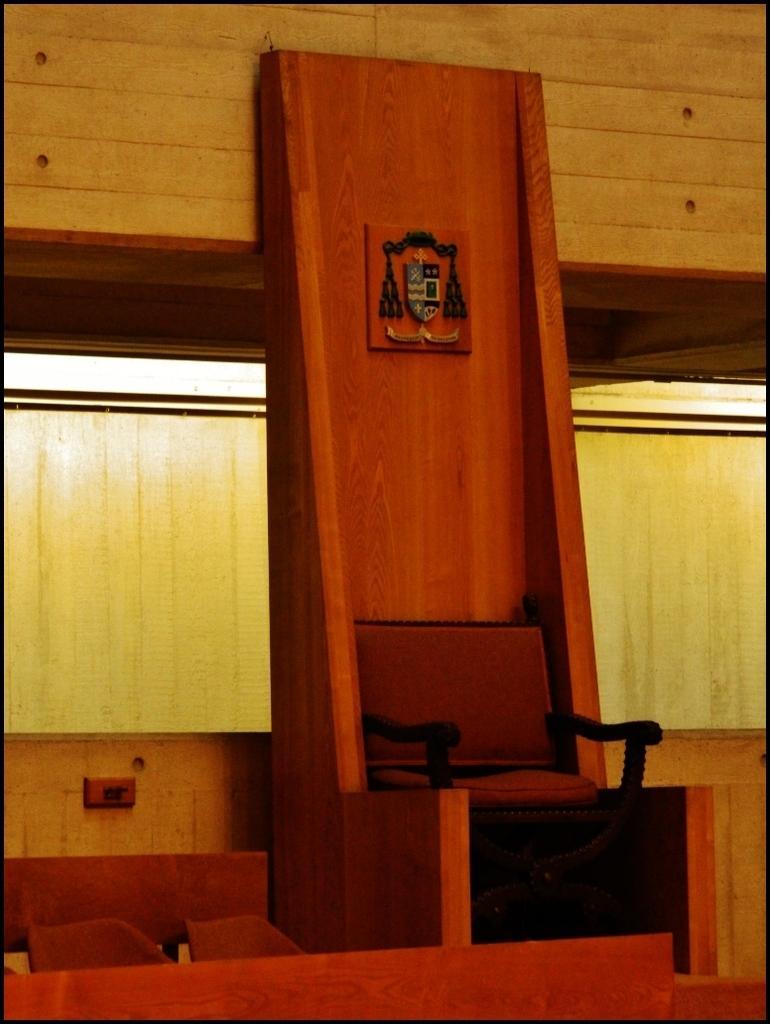In one or two sentences, can you explain what this image depicts? In this image I can see a chair kept on wooden stand and background I can see the wooden wall and there is another chair visible on the left side. 